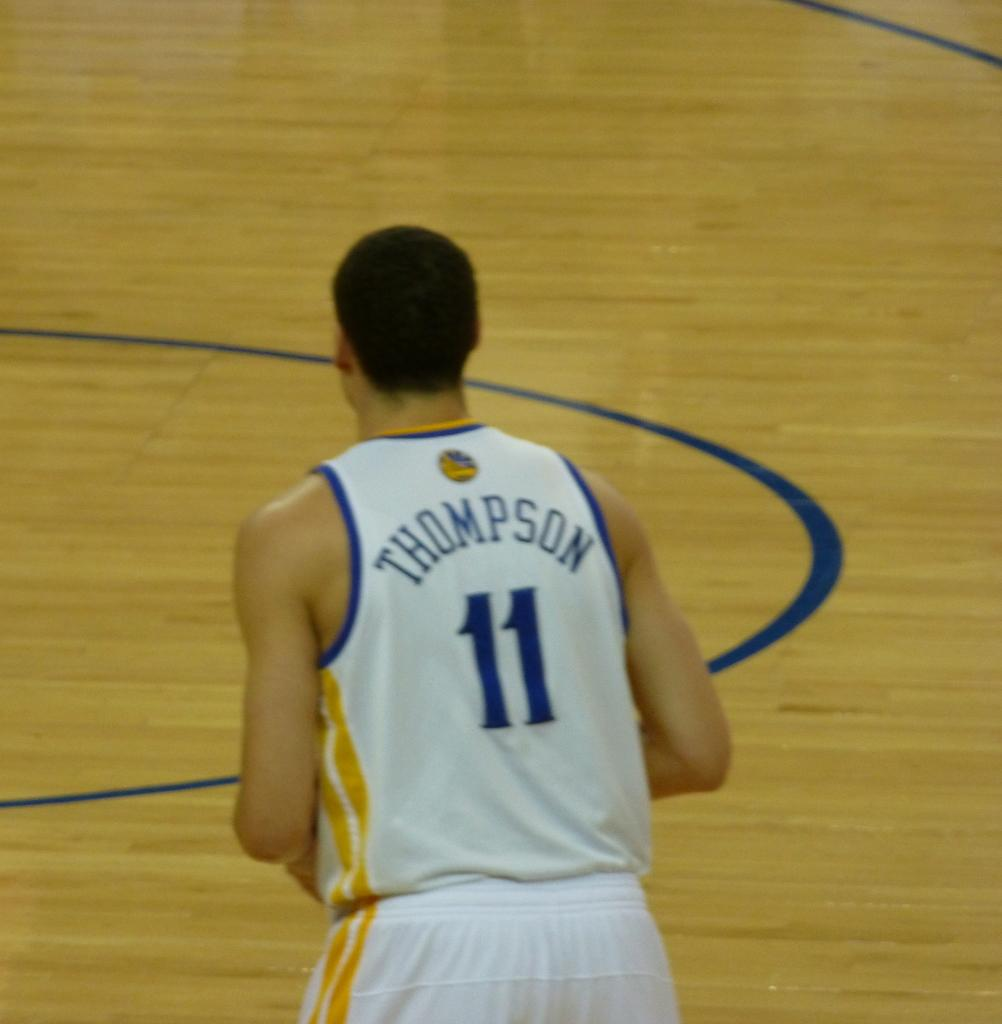<image>
Summarize the visual content of the image. A basketball player with the last name Thompson hurries down the court. 